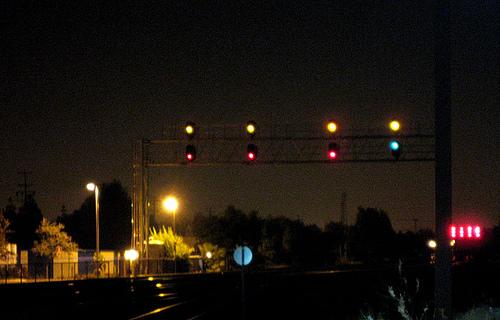What color is the bush on left?
Write a very short answer. Green. How many yellow lights?
Give a very brief answer. 4. What are the lights shown?
Quick response, please. Stop lights. Why are the lights on?
Write a very short answer. Night. What alternating colors are the lights for the hours?
Concise answer only. Red. Is this a town area?
Give a very brief answer. Yes. Are there many lights lit up?
Keep it brief. Yes. Is this a well populated area?
Keep it brief. No. What kind of tracks are in the picture?
Concise answer only. Train. Was this picture taken after sunset?
Answer briefly. Yes. 